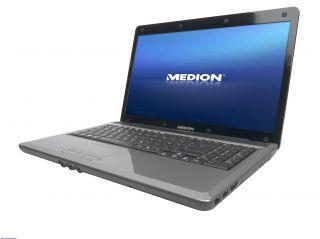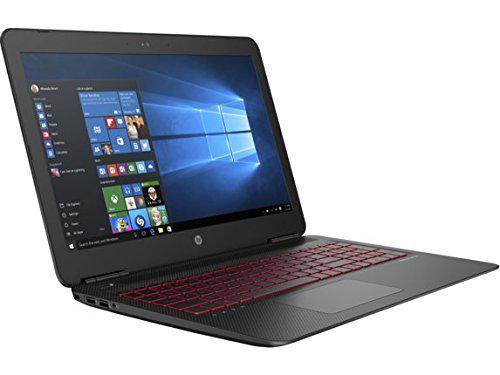The first image is the image on the left, the second image is the image on the right. For the images shown, is this caption "In at least one image there is a laptop with a blue screen and a sliver base near the keyboard." true? Answer yes or no. Yes. The first image is the image on the left, the second image is the image on the right. Considering the images on both sides, is "The laptop on the left is facing to the left." valid? Answer yes or no. Yes. 